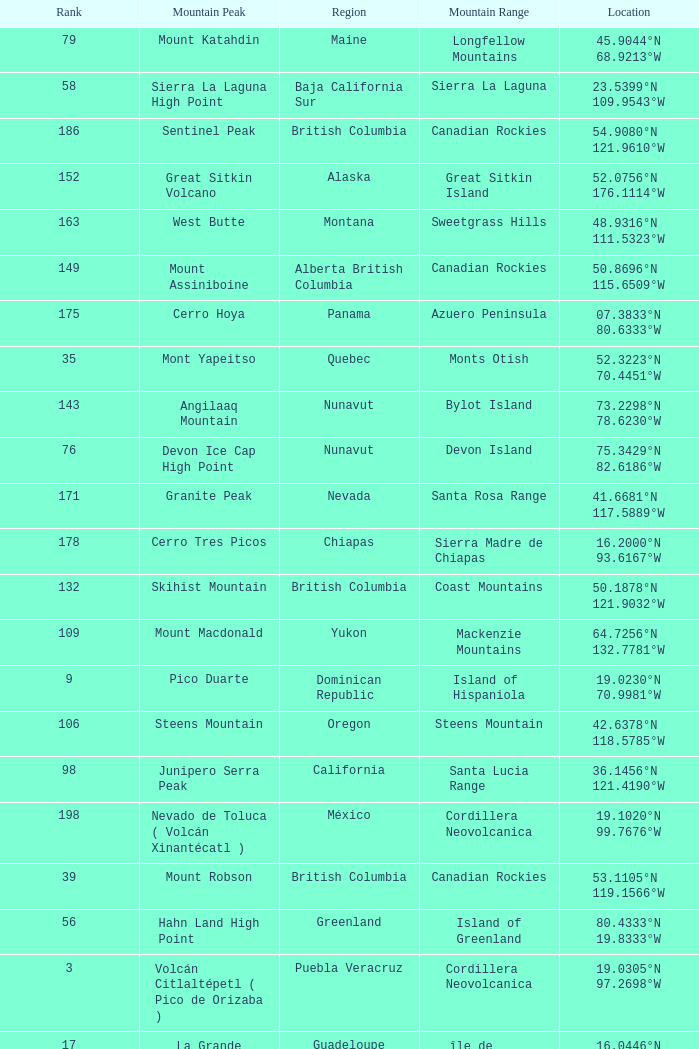Name the Region with a Mountain Peak of dillingham high point? Alaska. 